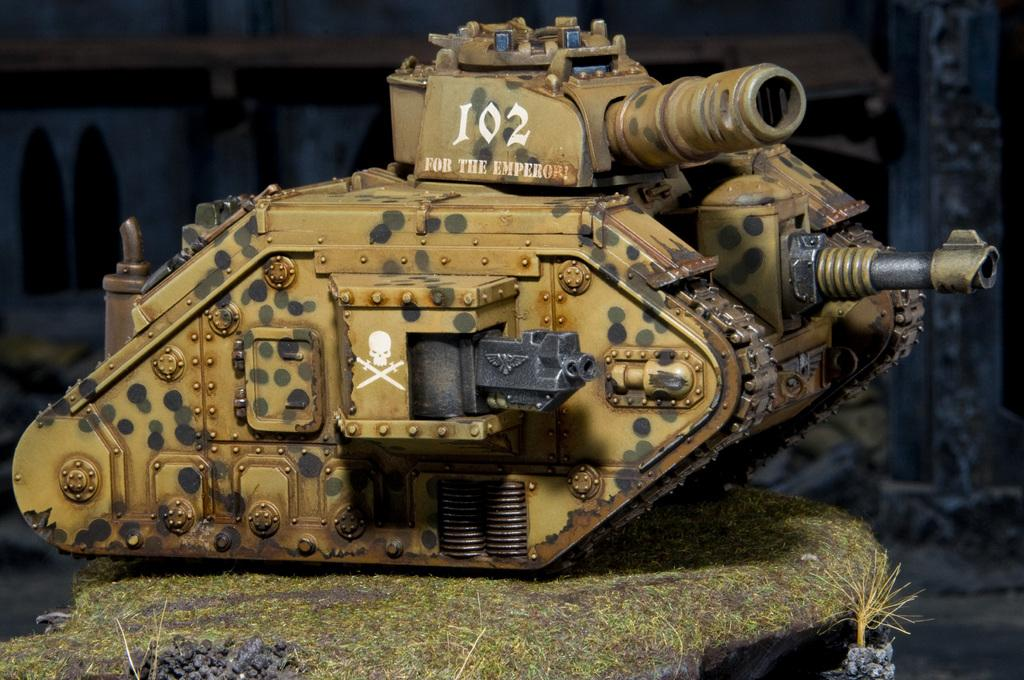What type of toy is on the ground in the image? There is a small military tank toy on the ground. What can be seen in the background of the image? There is a house made up of cardboard in the background. What type of cord is connected to the fowl in the image? There is no fowl or cord present in the image. 